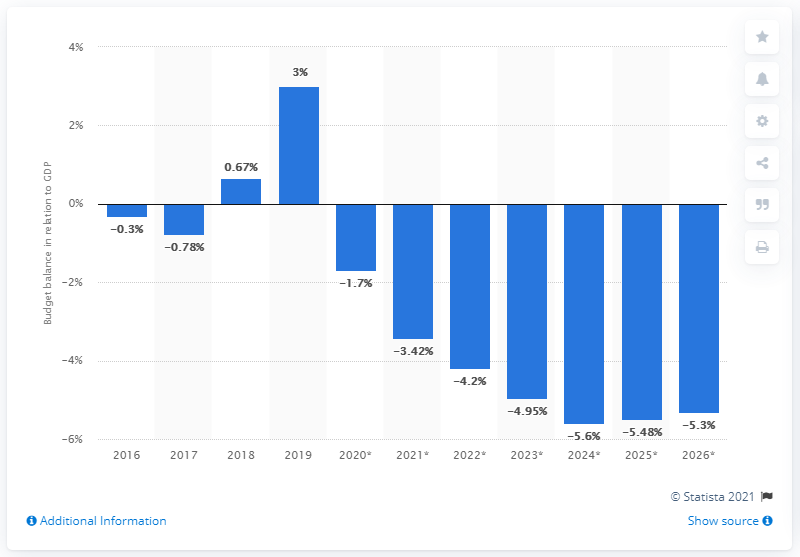Indicate a few pertinent items in this graphic. In 2019, Cambodia's budget surplus as a percentage of the country's Gross Domestic Product (GDP) was approximately 3%. 